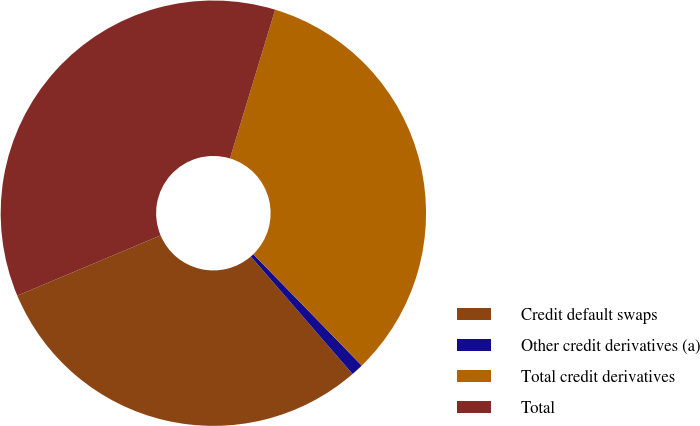<chart> <loc_0><loc_0><loc_500><loc_500><pie_chart><fcel>Credit default swaps<fcel>Other credit derivatives (a)<fcel>Total credit derivatives<fcel>Total<nl><fcel>30.02%<fcel>0.93%<fcel>33.02%<fcel>36.03%<nl></chart> 